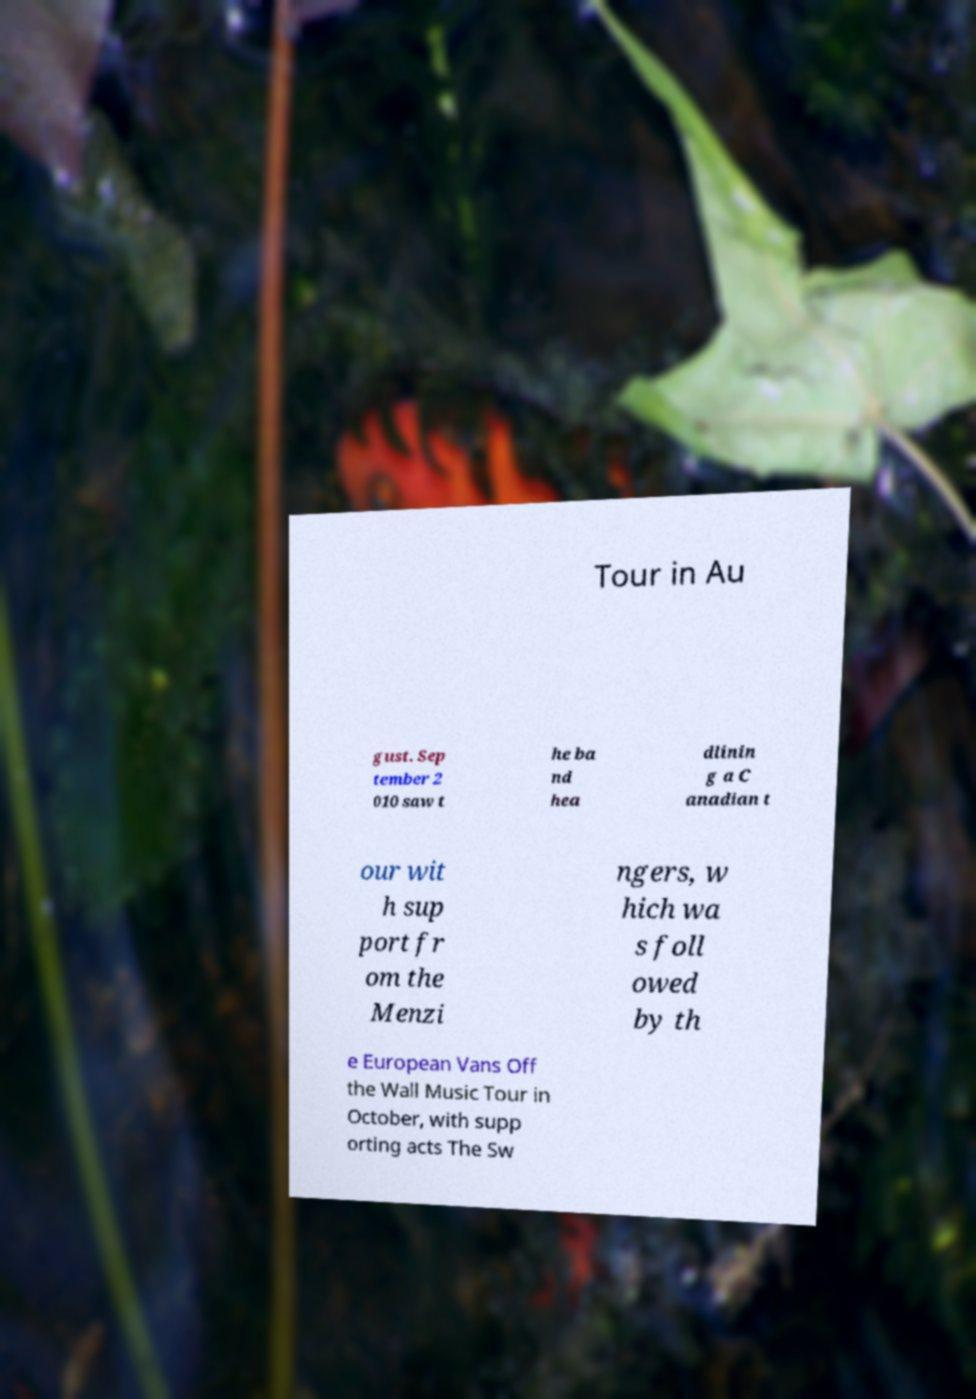Can you read and provide the text displayed in the image?This photo seems to have some interesting text. Can you extract and type it out for me? Tour in Au gust. Sep tember 2 010 saw t he ba nd hea dlinin g a C anadian t our wit h sup port fr om the Menzi ngers, w hich wa s foll owed by th e European Vans Off the Wall Music Tour in October, with supp orting acts The Sw 